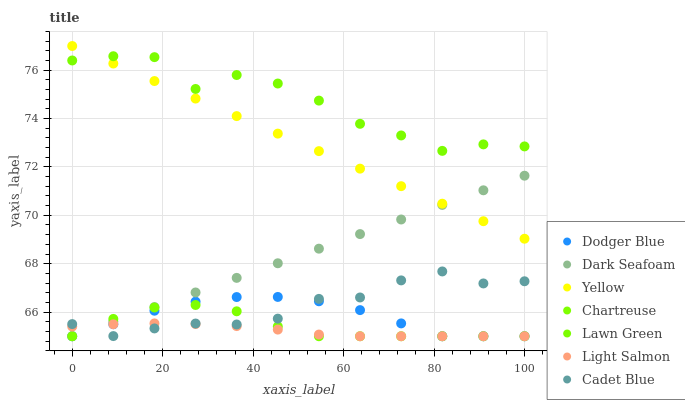Does Light Salmon have the minimum area under the curve?
Answer yes or no. Yes. Does Lawn Green have the maximum area under the curve?
Answer yes or no. Yes. Does Cadet Blue have the minimum area under the curve?
Answer yes or no. No. Does Cadet Blue have the maximum area under the curve?
Answer yes or no. No. Is Yellow the smoothest?
Answer yes or no. Yes. Is Lawn Green the roughest?
Answer yes or no. Yes. Is Light Salmon the smoothest?
Answer yes or no. No. Is Light Salmon the roughest?
Answer yes or no. No. Does Light Salmon have the lowest value?
Answer yes or no. Yes. Does Cadet Blue have the lowest value?
Answer yes or no. No. Does Yellow have the highest value?
Answer yes or no. Yes. Does Cadet Blue have the highest value?
Answer yes or no. No. Is Chartreuse less than Lawn Green?
Answer yes or no. Yes. Is Yellow greater than Cadet Blue?
Answer yes or no. Yes. Does Cadet Blue intersect Dark Seafoam?
Answer yes or no. Yes. Is Cadet Blue less than Dark Seafoam?
Answer yes or no. No. Is Cadet Blue greater than Dark Seafoam?
Answer yes or no. No. Does Chartreuse intersect Lawn Green?
Answer yes or no. No. 